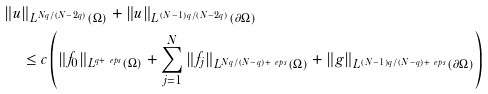<formula> <loc_0><loc_0><loc_500><loc_500>& \| u \| _ { L ^ { N q / ( N - 2 q ) } ( \Omega ) } + \| u \| _ { L ^ { ( N - 1 ) q / ( N - 2 q ) } ( \partial \Omega ) } \\ & \quad \leq c \left ( \| f _ { 0 } \| _ { L ^ { q + \ e p s } ( \Omega ) } + \sum _ { j = 1 } ^ { N } \| f _ { j } \| _ { L ^ { N q / ( N - q ) + \ e p s } ( \Omega ) } + \| g \| _ { L ^ { ( N - 1 ) q / ( N - q ) + \ e p s } ( \partial \Omega ) } \right )</formula> 